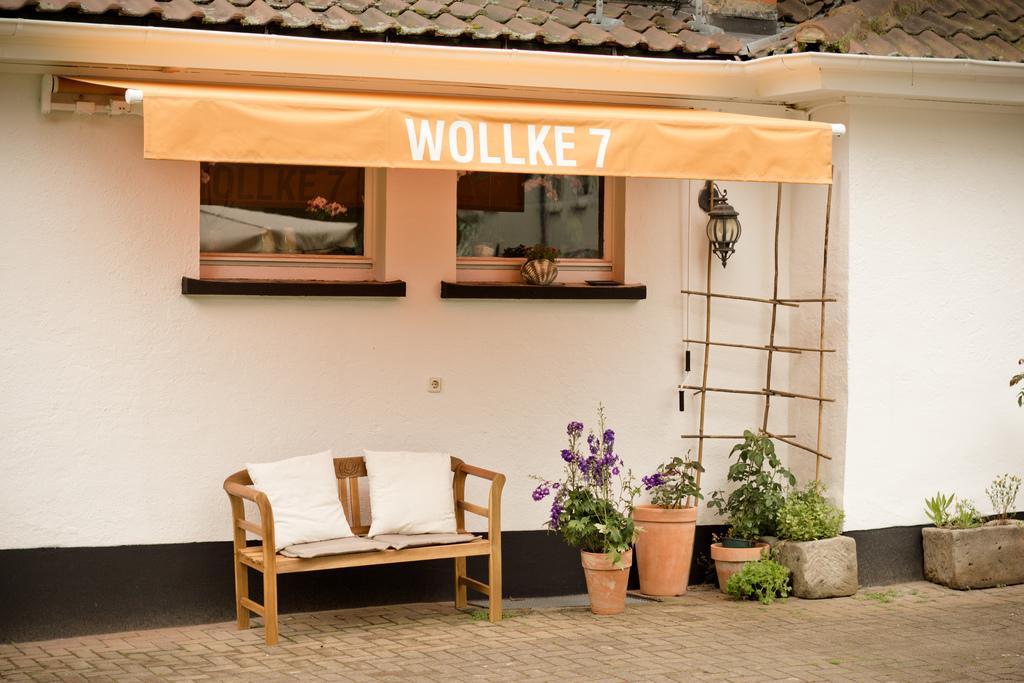Describe this image in one or two sentences. This is an outside view. Here I can see a bench on which two pillows are placed. Beside that there are some plants. In the background there is a wall and two windows. On the top of the image I can see the roof. 